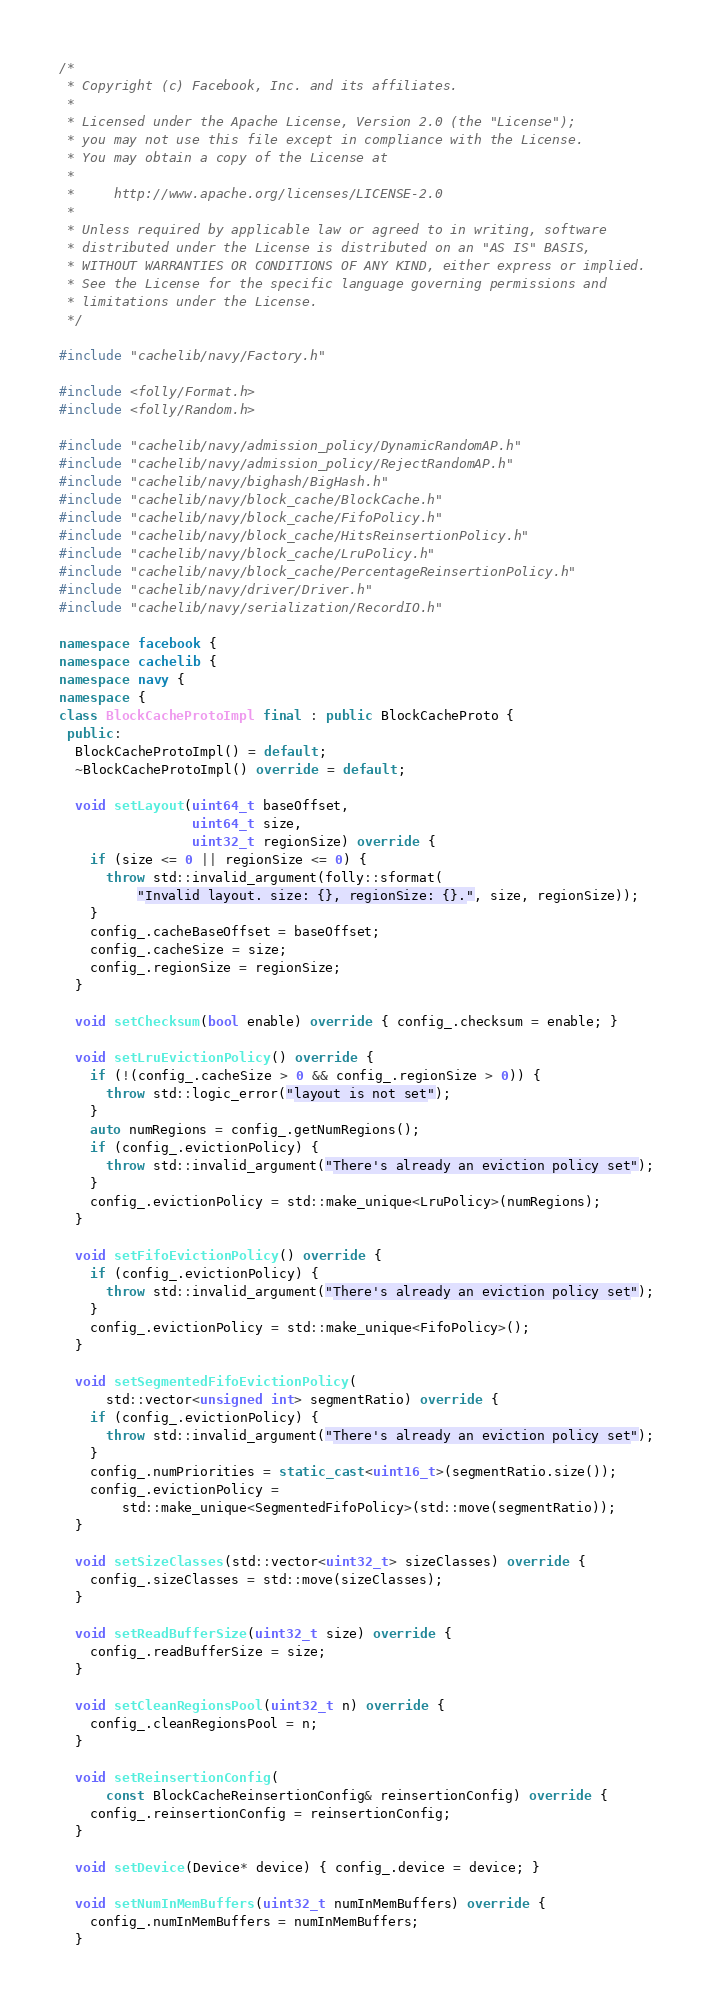<code> <loc_0><loc_0><loc_500><loc_500><_C++_>/*
 * Copyright (c) Facebook, Inc. and its affiliates.
 *
 * Licensed under the Apache License, Version 2.0 (the "License");
 * you may not use this file except in compliance with the License.
 * You may obtain a copy of the License at
 *
 *     http://www.apache.org/licenses/LICENSE-2.0
 *
 * Unless required by applicable law or agreed to in writing, software
 * distributed under the License is distributed on an "AS IS" BASIS,
 * WITHOUT WARRANTIES OR CONDITIONS OF ANY KIND, either express or implied.
 * See the License for the specific language governing permissions and
 * limitations under the License.
 */

#include "cachelib/navy/Factory.h"

#include <folly/Format.h>
#include <folly/Random.h>

#include "cachelib/navy/admission_policy/DynamicRandomAP.h"
#include "cachelib/navy/admission_policy/RejectRandomAP.h"
#include "cachelib/navy/bighash/BigHash.h"
#include "cachelib/navy/block_cache/BlockCache.h"
#include "cachelib/navy/block_cache/FifoPolicy.h"
#include "cachelib/navy/block_cache/HitsReinsertionPolicy.h"
#include "cachelib/navy/block_cache/LruPolicy.h"
#include "cachelib/navy/block_cache/PercentageReinsertionPolicy.h"
#include "cachelib/navy/driver/Driver.h"
#include "cachelib/navy/serialization/RecordIO.h"

namespace facebook {
namespace cachelib {
namespace navy {
namespace {
class BlockCacheProtoImpl final : public BlockCacheProto {
 public:
  BlockCacheProtoImpl() = default;
  ~BlockCacheProtoImpl() override = default;

  void setLayout(uint64_t baseOffset,
                 uint64_t size,
                 uint32_t regionSize) override {
    if (size <= 0 || regionSize <= 0) {
      throw std::invalid_argument(folly::sformat(
          "Invalid layout. size: {}, regionSize: {}.", size, regionSize));
    }
    config_.cacheBaseOffset = baseOffset;
    config_.cacheSize = size;
    config_.regionSize = regionSize;
  }

  void setChecksum(bool enable) override { config_.checksum = enable; }

  void setLruEvictionPolicy() override {
    if (!(config_.cacheSize > 0 && config_.regionSize > 0)) {
      throw std::logic_error("layout is not set");
    }
    auto numRegions = config_.getNumRegions();
    if (config_.evictionPolicy) {
      throw std::invalid_argument("There's already an eviction policy set");
    }
    config_.evictionPolicy = std::make_unique<LruPolicy>(numRegions);
  }

  void setFifoEvictionPolicy() override {
    if (config_.evictionPolicy) {
      throw std::invalid_argument("There's already an eviction policy set");
    }
    config_.evictionPolicy = std::make_unique<FifoPolicy>();
  }

  void setSegmentedFifoEvictionPolicy(
      std::vector<unsigned int> segmentRatio) override {
    if (config_.evictionPolicy) {
      throw std::invalid_argument("There's already an eviction policy set");
    }
    config_.numPriorities = static_cast<uint16_t>(segmentRatio.size());
    config_.evictionPolicy =
        std::make_unique<SegmentedFifoPolicy>(std::move(segmentRatio));
  }

  void setSizeClasses(std::vector<uint32_t> sizeClasses) override {
    config_.sizeClasses = std::move(sizeClasses);
  }

  void setReadBufferSize(uint32_t size) override {
    config_.readBufferSize = size;
  }

  void setCleanRegionsPool(uint32_t n) override {
    config_.cleanRegionsPool = n;
  }

  void setReinsertionConfig(
      const BlockCacheReinsertionConfig& reinsertionConfig) override {
    config_.reinsertionConfig = reinsertionConfig;
  }

  void setDevice(Device* device) { config_.device = device; }

  void setNumInMemBuffers(uint32_t numInMemBuffers) override {
    config_.numInMemBuffers = numInMemBuffers;
  }
</code> 